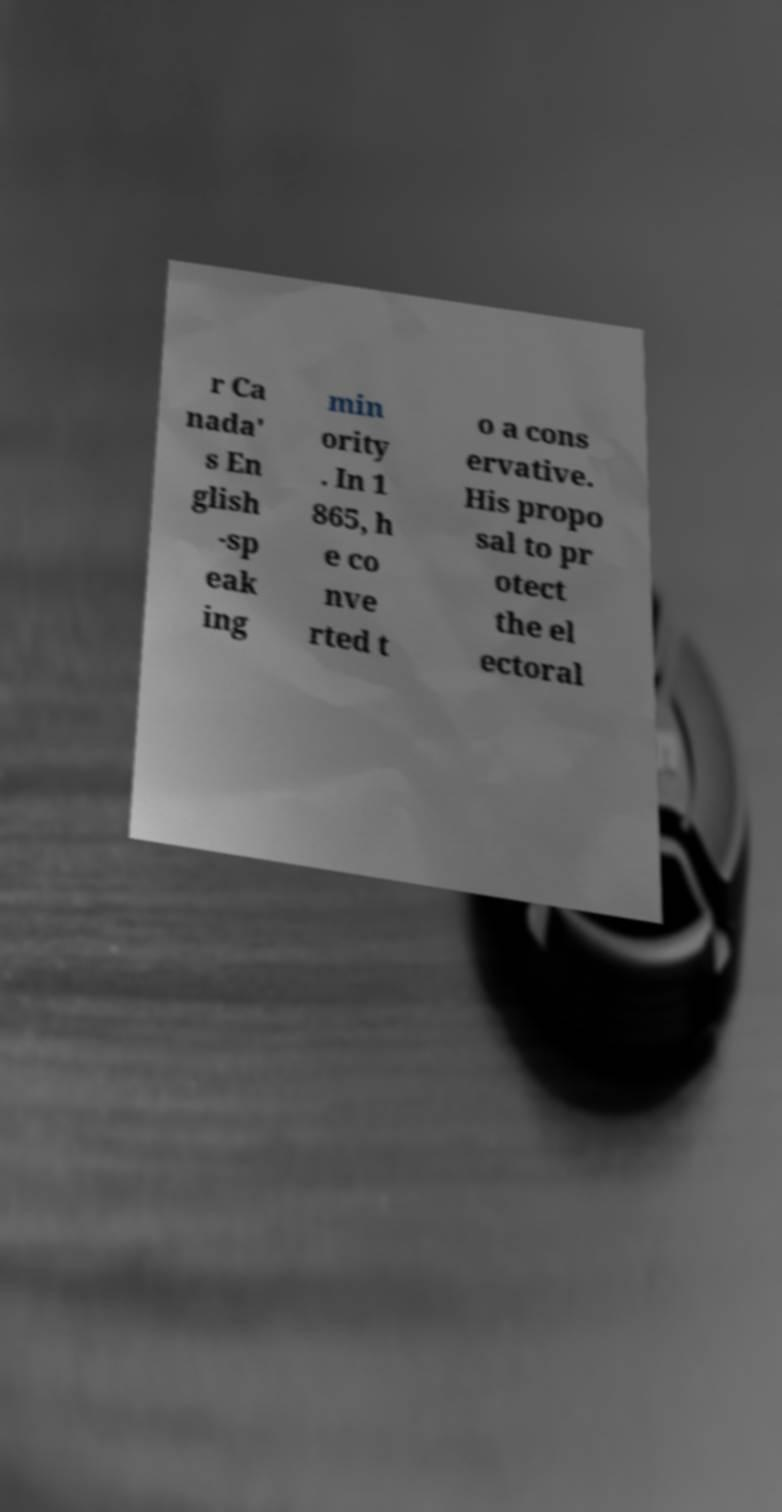I need the written content from this picture converted into text. Can you do that? r Ca nada' s En glish -sp eak ing min ority . In 1 865, h e co nve rted t o a cons ervative. His propo sal to pr otect the el ectoral 